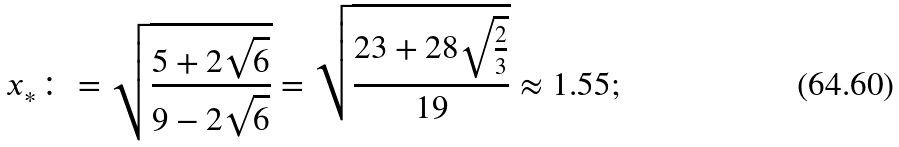<formula> <loc_0><loc_0><loc_500><loc_500>x _ { * } \colon = \sqrt { \frac { 5 + 2 \sqrt { 6 } } { 9 - 2 \sqrt { 6 } } } = \sqrt { \frac { 2 3 + 2 8 \sqrt { \frac { 2 } { 3 } } } { 1 9 } } \approx 1 . 5 5 ;</formula> 